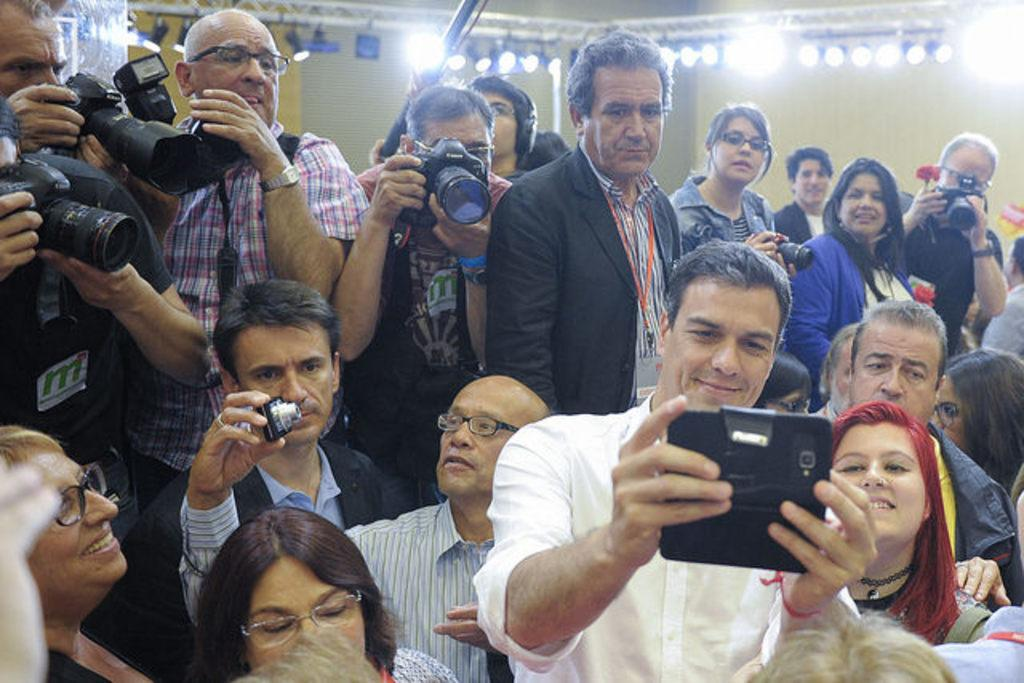How many people are in the image? There is a group of persons in the image. Where are the persons located? The persons are in a room. What are the persons holding in the image? The persons are holding cameras. What can be seen in the background of the image? There are lights in the background of the image. What type of chain is hanging from the shelf in the image? There is no chain or shelf present in the image. What is the base of the camera that the person is holding? The provided facts do not mention the base of the camera, only that the persons are holding cameras. 